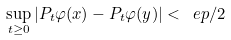Convert formula to latex. <formula><loc_0><loc_0><loc_500><loc_500>\sup _ { t \geq 0 } | P _ { t } \varphi ( x ) - P _ { t } \varphi ( y ) | < \ e p / 2</formula> 